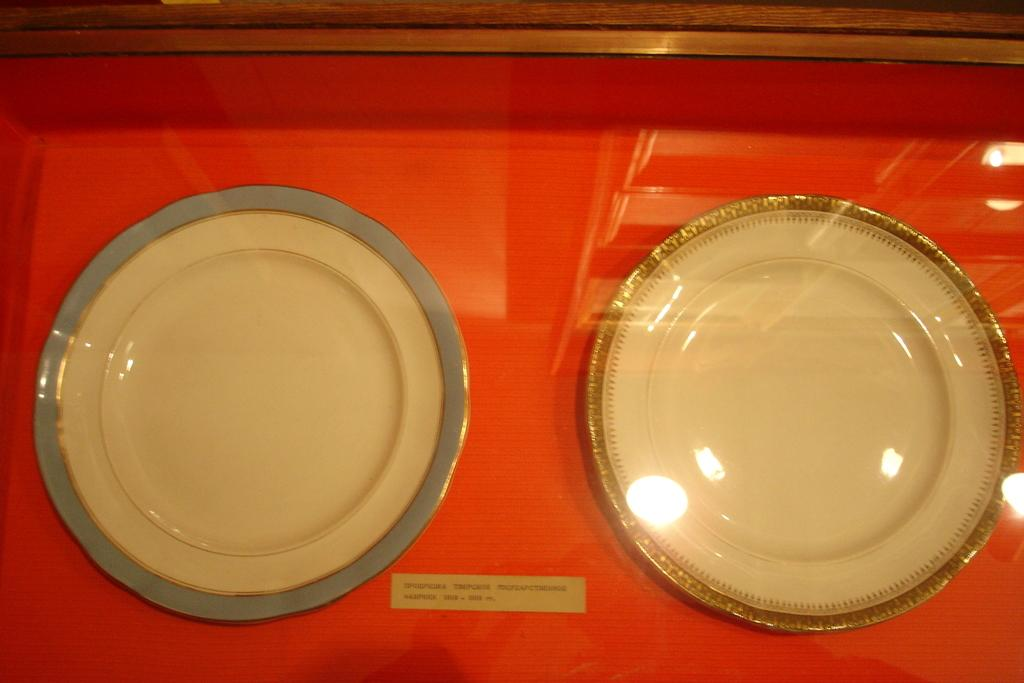What objects are present on the surface in the image? There are empty plates on the surface in the image. What is the color of the surface the plates are on? The surface the plates are on is red in color. Is there any writing or text on the surface? Yes, there is text written on the surface. Can you see your partner writing on the seashore in the image? There is no partner or seashore present in the image; it only features empty plates on a red surface with text. 